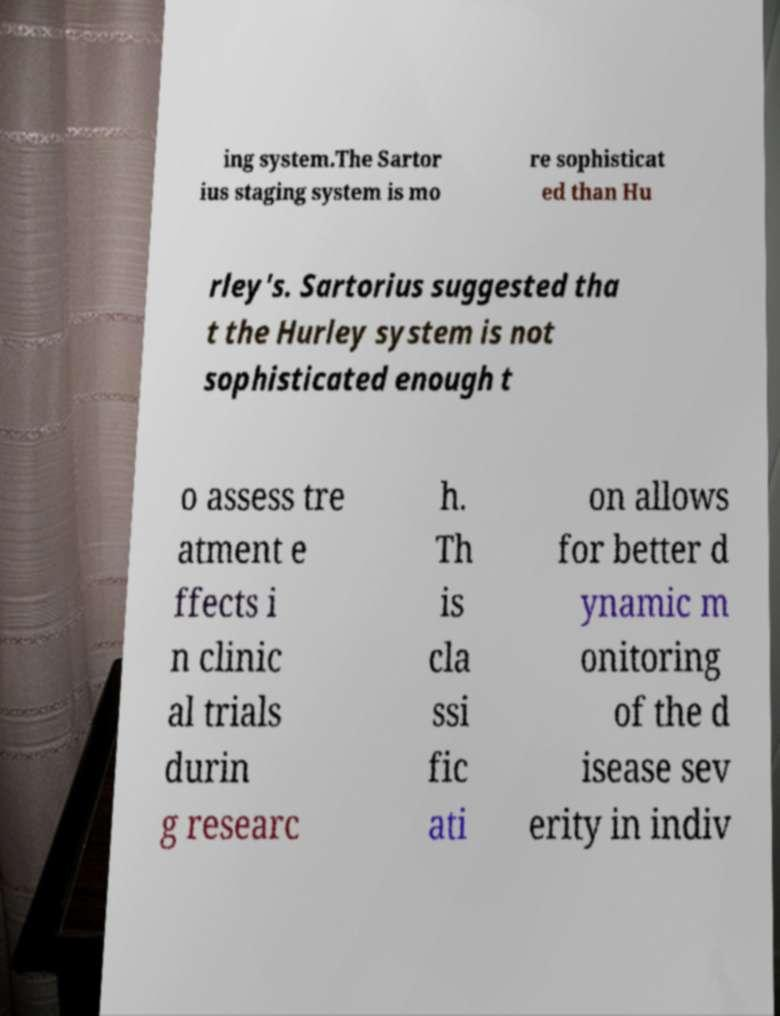Can you accurately transcribe the text from the provided image for me? ing system.The Sartor ius staging system is mo re sophisticat ed than Hu rley's. Sartorius suggested tha t the Hurley system is not sophisticated enough t o assess tre atment e ffects i n clinic al trials durin g researc h. Th is cla ssi fic ati on allows for better d ynamic m onitoring of the d isease sev erity in indiv 